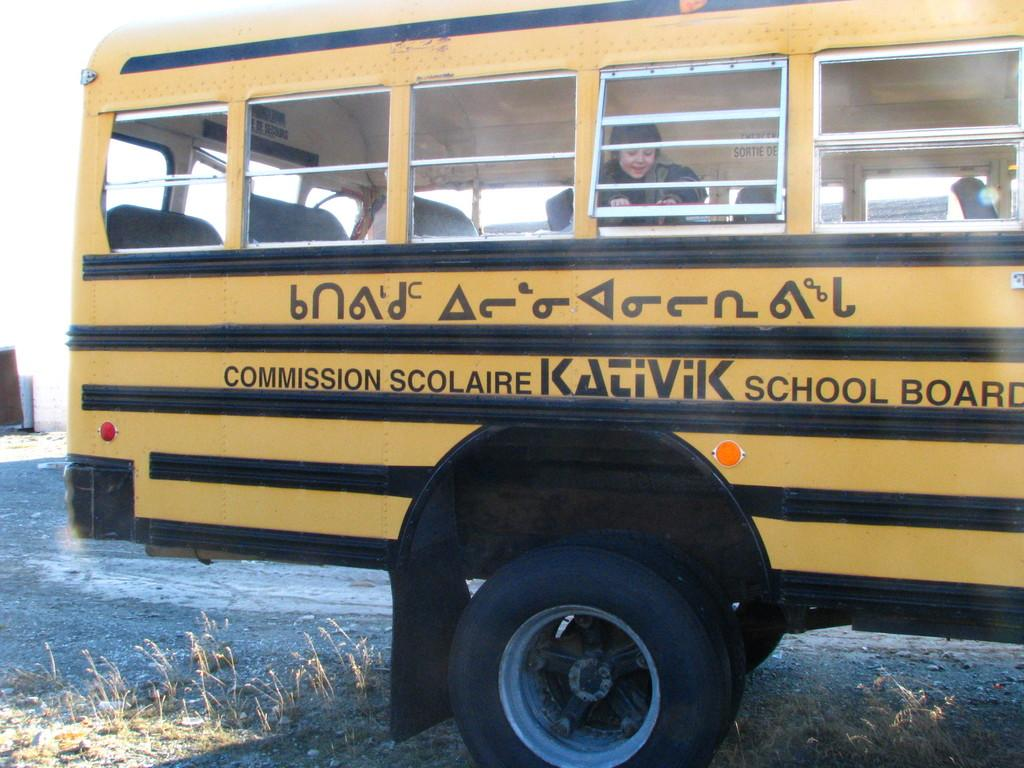What is the main subject of the image? There is a girl inside a school bus in the image. What type of surface is visible at the bottom of the image? Grass is visible at the bottom portion of the image. Are there any plants visible in the image? Yes, tiny plants are present on the road in the image. What type of ornament is hanging from the school bus in the image? There is no ornament hanging from the school bus in the image. Can you read the note that the girl is holding in the image? There is no note visible in the image. 